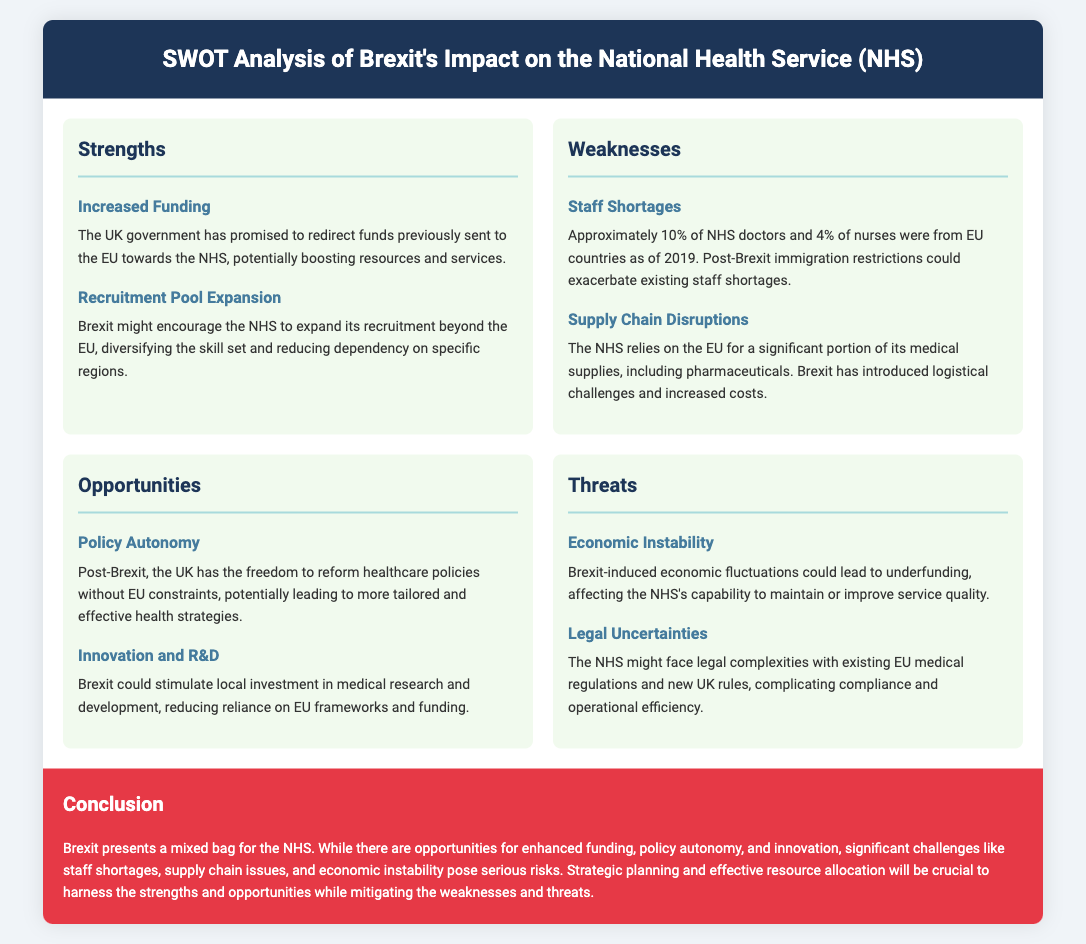What is one of the strengths of Brexit’s impact on the NHS? The document lists "Increased Funding" as a strength, referring to the potential boost in resources and services from redirected EU funds.
Answer: Increased Funding What percentage of NHS doctors were from EU countries as of 2019? The document states that approximately 10% of NHS doctors were from EU countries before Brexit, highlighting a significant dependency on EU medical staff.
Answer: 10% What opportunity does Brexit provide regarding healthcare policies? The analysis mentions "Policy Autonomy" as an opportunity, suggesting that the UK can reform healthcare policies without EU constraints post-Brexit.
Answer: Policy Autonomy What is a notable threat to the NHS mentioned in the SWOT analysis? The document indicates that "Economic Instability" could be a threat, which may lead to underfunding and affect service quality.
Answer: Economic Instability What is one potential impact on NHS innovation after Brexit? The document notes "Innovation and R&D" as a possible benefit, indicating that local investment in medical research and development may increase.
Answer: Innovation and R&D What key aspect of NHS operations is affected by Brexit-related supply chain issues? The document highlights "Supply Chain Disruptions" as a weakness, detailing the reliance on the EU for medical supplies and pharmaceuticals.
Answer: Supply Chain Disruptions How does Brexit affect the NHS recruitment pool? The document mentions "Recruitment Pool Expansion," suggesting a diversification of skill sets and reduced dependency on specific regions for NHS staff.
Answer: Recruitment Pool Expansion What are the two aspects of Brexit that present both opportunities and challenges for the NHS? The analysis concludes with mixed outcomes, identifying "strengths" and "opportunities" on one hand, and "weaknesses" and "threats" on the other, stressing the need for strategic planning.
Answer: Strengths and Weaknesses What does the conclusion emphasize as essential for the future of the NHS post-Brexit? The document emphasizes the importance of "strategic planning and effective resource allocation" to navigate the opportunities and challenges identified.
Answer: Strategic planning 